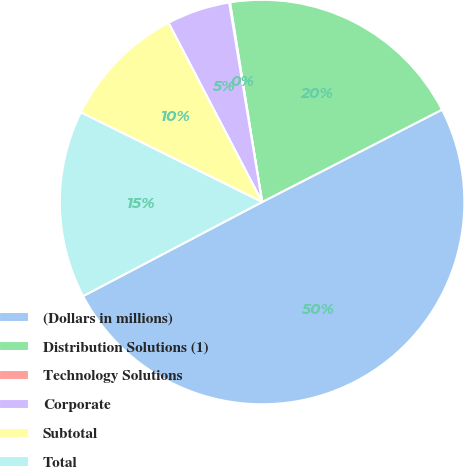Convert chart to OTSL. <chart><loc_0><loc_0><loc_500><loc_500><pie_chart><fcel>(Dollars in millions)<fcel>Distribution Solutions (1)<fcel>Technology Solutions<fcel>Corporate<fcel>Subtotal<fcel>Total<nl><fcel>49.85%<fcel>19.99%<fcel>0.07%<fcel>5.05%<fcel>10.03%<fcel>15.01%<nl></chart> 